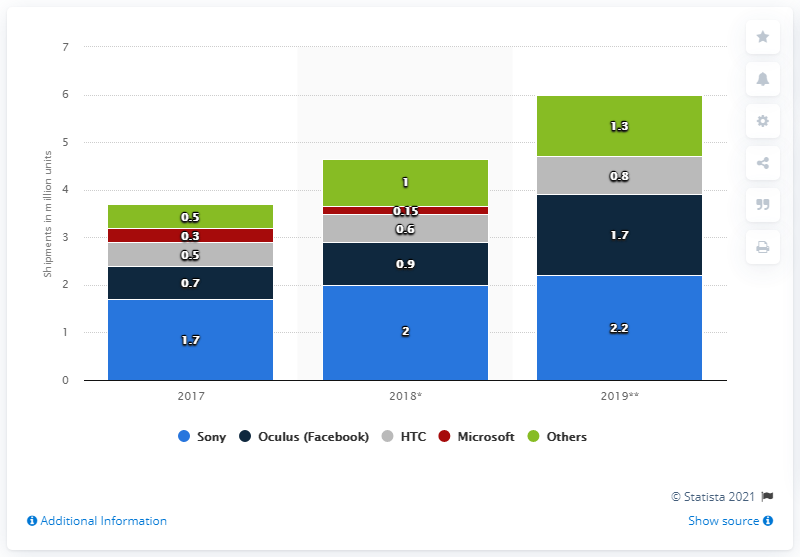Specify some key components in this picture. According to forecasts, the unit shipments of VR devices in 2019 are expected to be approximately 2.2.. 